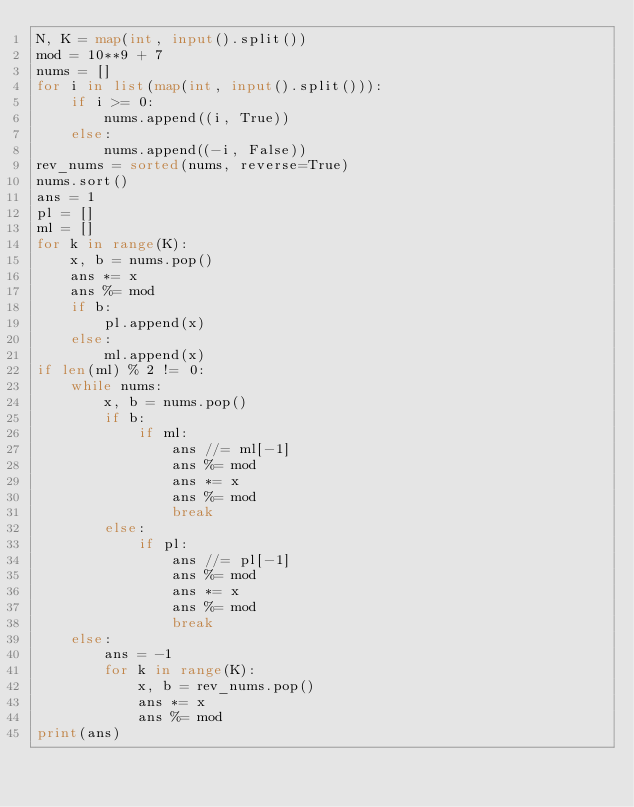<code> <loc_0><loc_0><loc_500><loc_500><_Python_>N, K = map(int, input().split())
mod = 10**9 + 7
nums = []
for i in list(map(int, input().split())):
    if i >= 0:
        nums.append((i, True))
    else:
        nums.append((-i, False))
rev_nums = sorted(nums, reverse=True)
nums.sort()
ans = 1
pl = []
ml = []
for k in range(K):
    x, b = nums.pop()
    ans *= x
    ans %= mod
    if b:
        pl.append(x)
    else:
        ml.append(x)
if len(ml) % 2 != 0:
    while nums:
        x, b = nums.pop()
        if b:
            if ml:
                ans //= ml[-1]
                ans %= mod
                ans *= x
                ans %= mod
                break
        else:
            if pl:
                ans //= pl[-1]
                ans %= mod
                ans *= x
                ans %= mod
                break
    else:
        ans = -1
        for k in range(K):
            x, b = rev_nums.pop()
            ans *= x
            ans %= mod
print(ans)</code> 